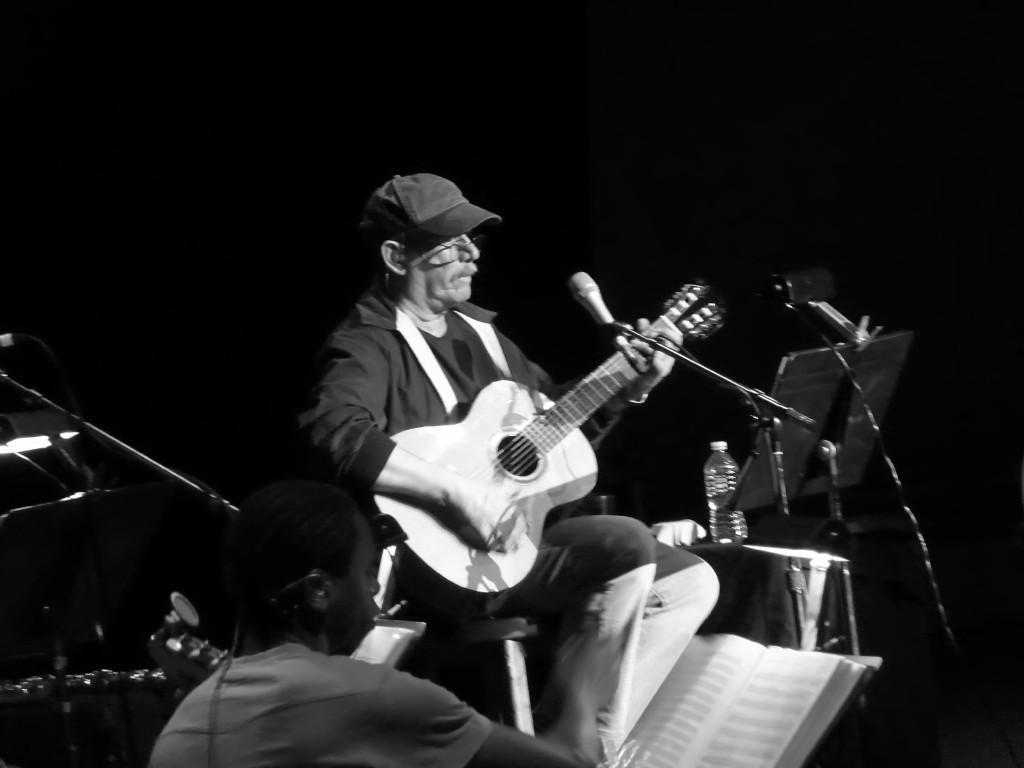How would you summarize this image in a sentence or two? There is a man in the image who is sitting on chair and holding a guitar and playing it in front of a microphone. On left side there is a another man holding a book on his hands, in background we can see a water bottle,table. 